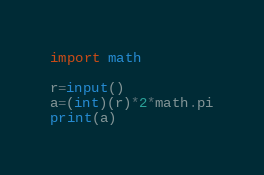<code> <loc_0><loc_0><loc_500><loc_500><_Python_>import math

r=input()
a=(int)(r)*2*math.pi
print(a)
</code> 